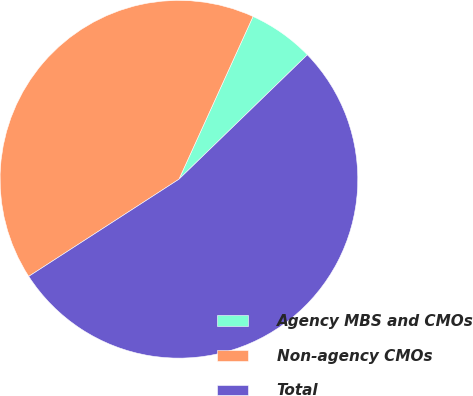Convert chart to OTSL. <chart><loc_0><loc_0><loc_500><loc_500><pie_chart><fcel>Agency MBS and CMOs<fcel>Non-agency CMOs<fcel>Total<nl><fcel>5.95%<fcel>40.94%<fcel>53.12%<nl></chart> 